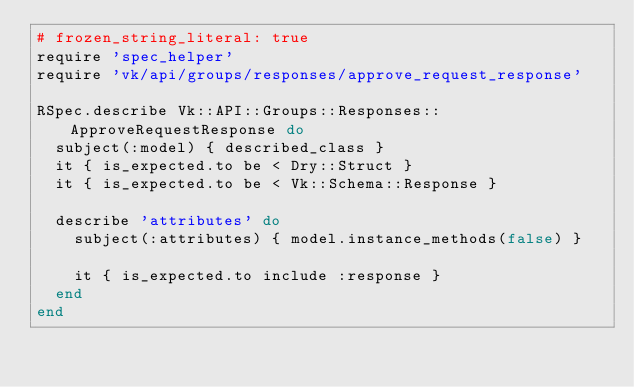<code> <loc_0><loc_0><loc_500><loc_500><_Ruby_># frozen_string_literal: true
require 'spec_helper'
require 'vk/api/groups/responses/approve_request_response'

RSpec.describe Vk::API::Groups::Responses::ApproveRequestResponse do
  subject(:model) { described_class }
  it { is_expected.to be < Dry::Struct }
  it { is_expected.to be < Vk::Schema::Response }

  describe 'attributes' do
    subject(:attributes) { model.instance_methods(false) }

    it { is_expected.to include :response }
  end
end
</code> 